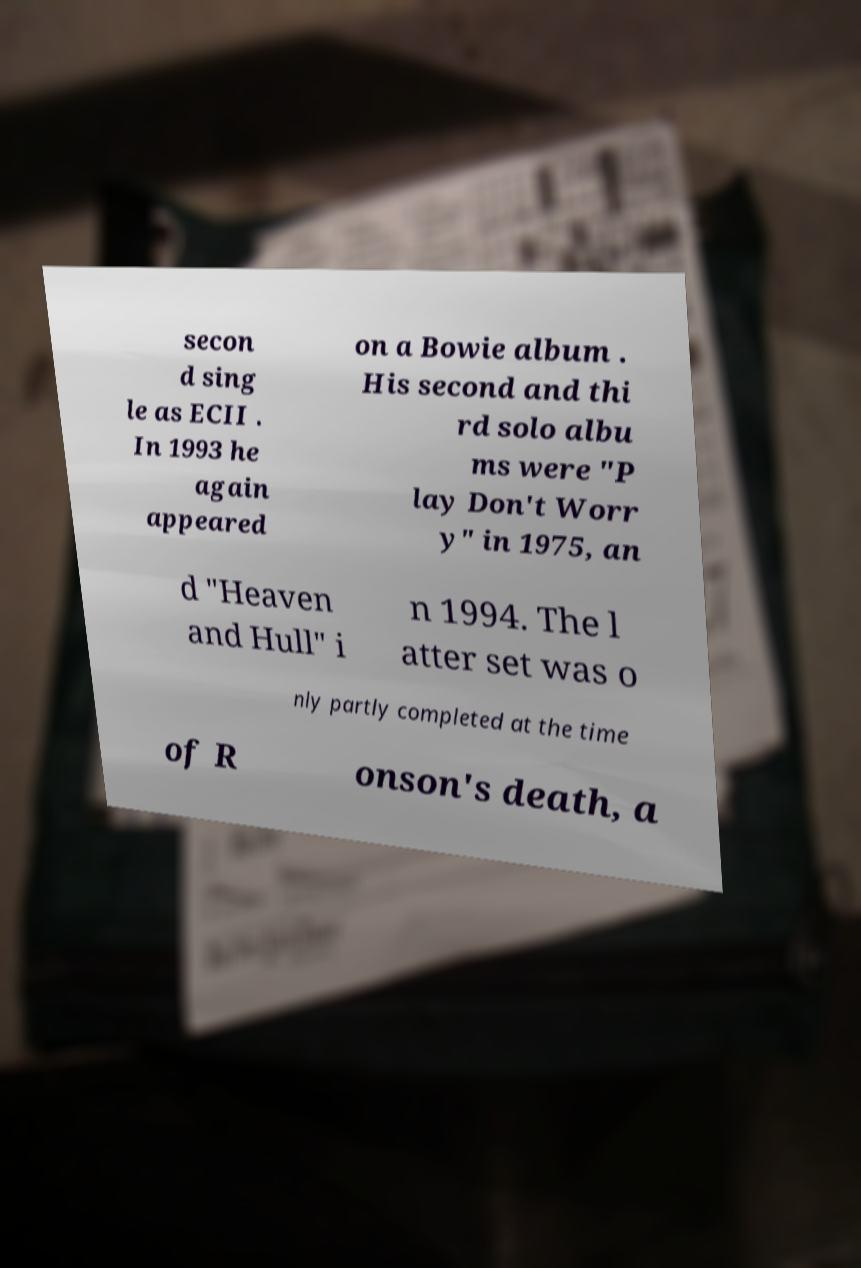Could you assist in decoding the text presented in this image and type it out clearly? secon d sing le as ECII . In 1993 he again appeared on a Bowie album . His second and thi rd solo albu ms were "P lay Don't Worr y" in 1975, an d "Heaven and Hull" i n 1994. The l atter set was o nly partly completed at the time of R onson's death, a 